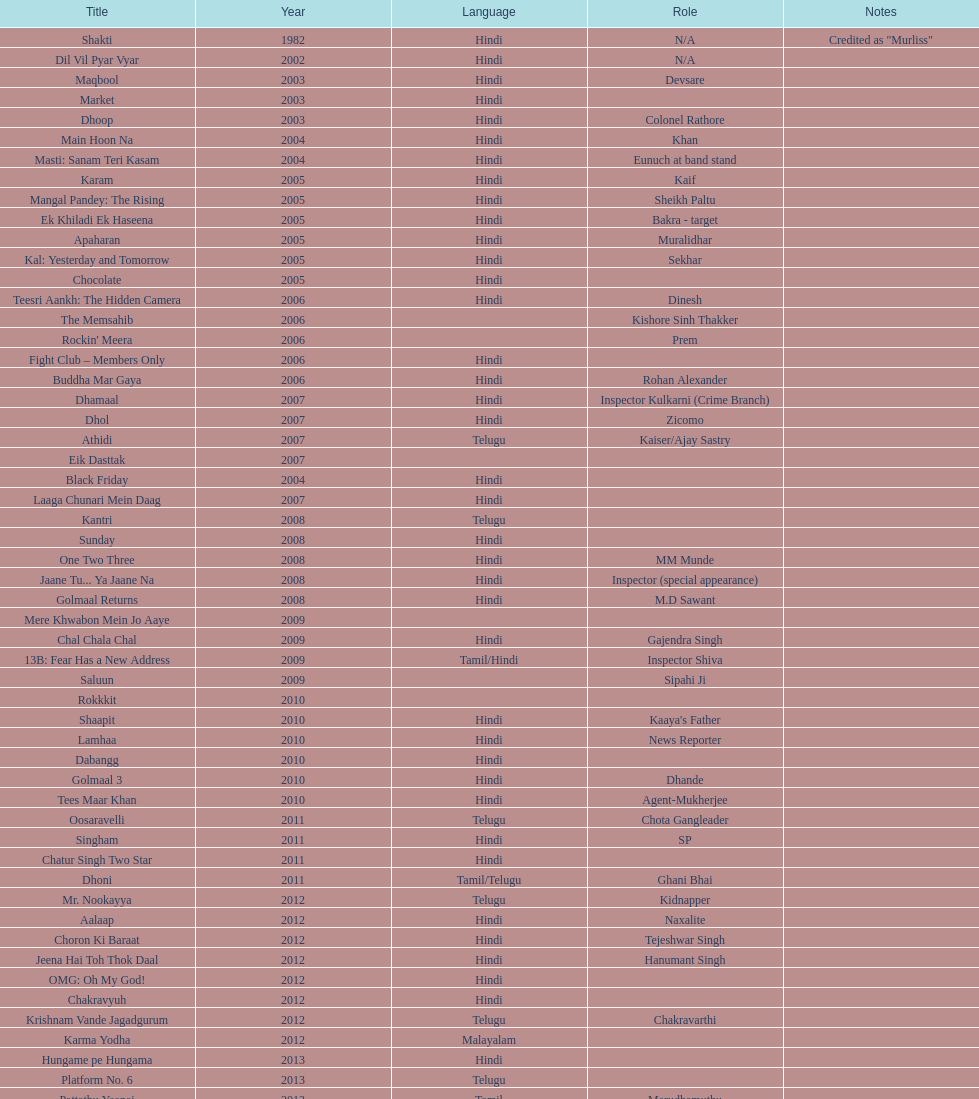In which last malayalam cinema did this actor perform? Karma Yodha. 